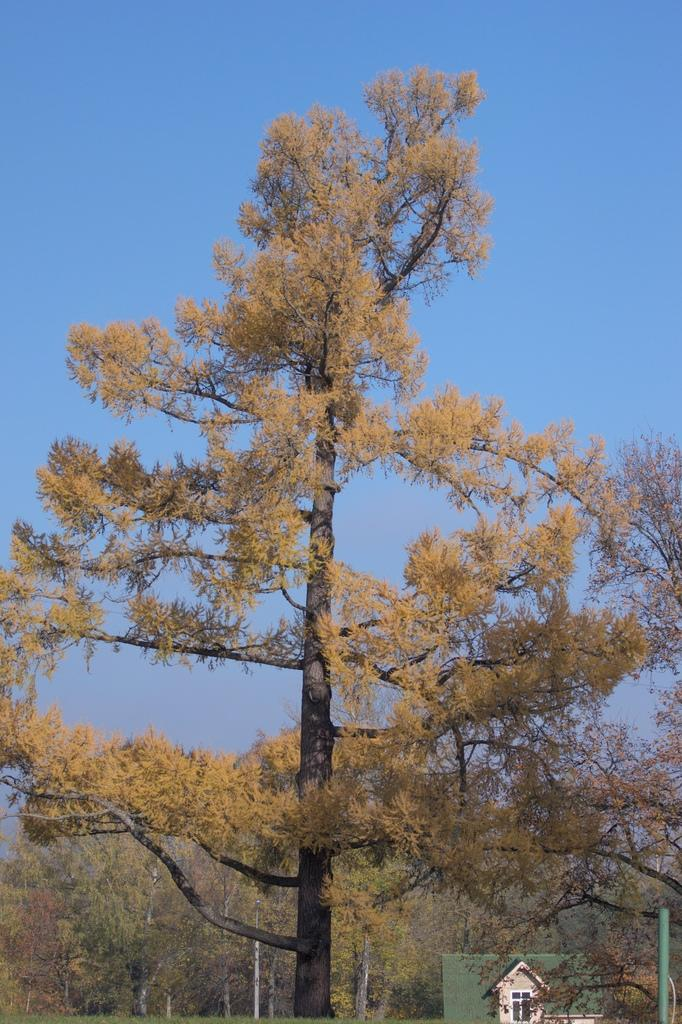What type of natural vegetation is present in the image? There are many trees in the image. What type of structure can be seen in the image? There is a house in the image. What other object can be seen in the image besides the house and trees? There is a pole in the image. What is visible in the background of the image? The sky is visible in the background of the image. What type of trouble can be seen in the image? There is no trouble present in the image; it features trees, a house, and a pole. What type of wine is being served in the image? There is no wine present in the image. 